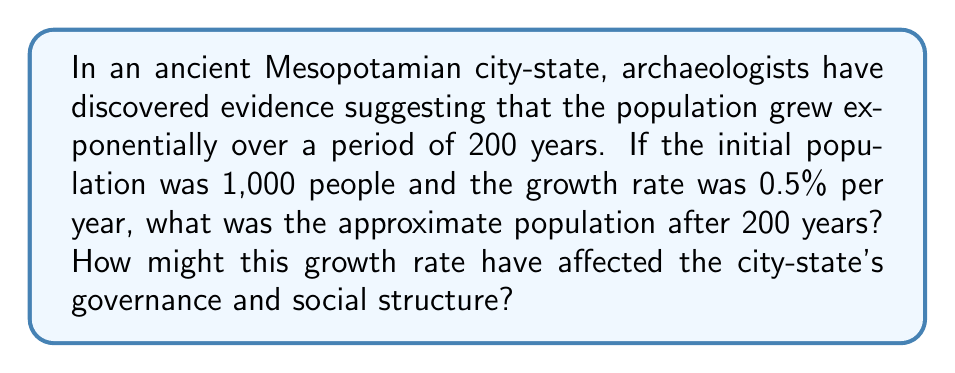Provide a solution to this math problem. To solve this problem, we'll use the exponential growth formula:

$$P(t) = P_0 \cdot e^{rt}$$

Where:
$P(t)$ is the population at time $t$
$P_0$ is the initial population
$e$ is Euler's number (approximately 2.71828)
$r$ is the growth rate (as a decimal)
$t$ is the time period

Given:
$P_0 = 1,000$
$r = 0.005$ (0.5% expressed as a decimal)
$t = 200$ years

Let's substitute these values into the formula:

$$P(200) = 1,000 \cdot e^{0.005 \cdot 200}$$

$$P(200) = 1,000 \cdot e^1$$

$$P(200) = 1,000 \cdot 2.71828$$

$$P(200) \approx 2,718$$

The population after 200 years would be approximately 2,718 people.

Regarding governance and social structure:
1. This growth rate might have led to the development of more complex administrative systems to manage the increasing population.
2. The city-state may have needed to expand its agricultural practices or trade networks to support the growing population.
3. Social stratification might have become more pronounced as the population increased, potentially leading to the emergence of distinct social classes.
4. The growth could have stimulated technological advancements to meet the needs of a larger population.
5. Political structures might have evolved to accommodate the representation of a larger and more diverse citizenry.
Answer: 2,718 people; potential impacts include more complex administration, expanded resources, increased social stratification, technological advancements, and evolving political structures. 